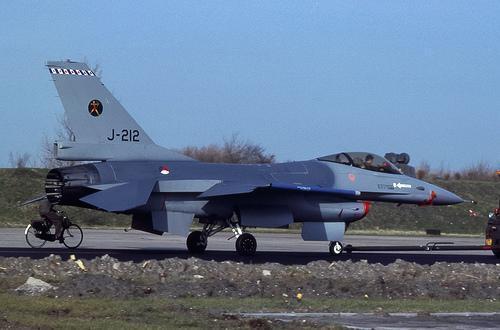How many bicycles?
Give a very brief answer. 1. How many wheels total?
Give a very brief answer. 5. 